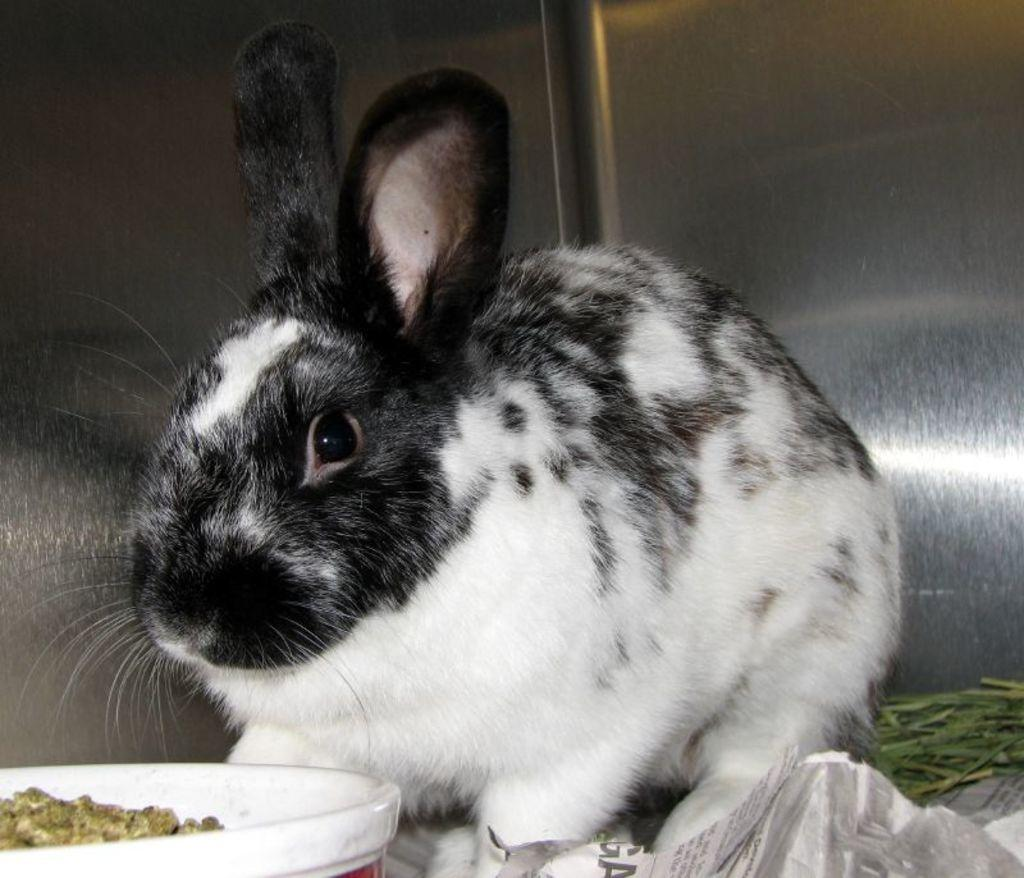What animal can be seen in the image? There is a rabbit in the image. Where is the rabbit located? The rabbit is on the floor. What is the rabbit near? The rabbit is near some grass. What other objects are present in the image? There is a paper, a bowl, and food in the bowl. Can you describe the background of the image? There is a wall in the background of the image. What type of vegetation is visible in the image? There is grass on the right side of the image. What type of hook can be seen in the image? There is no hook present in the image. 